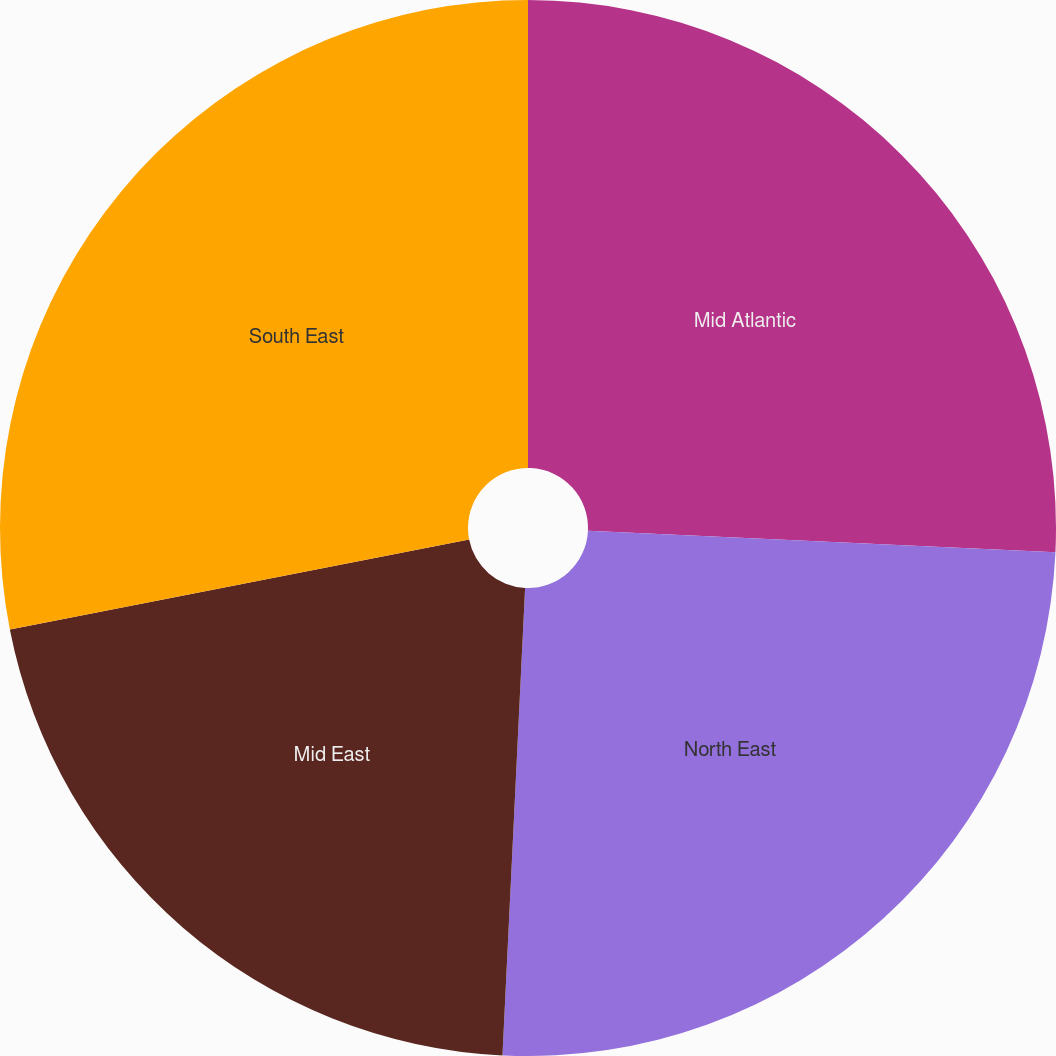Convert chart to OTSL. <chart><loc_0><loc_0><loc_500><loc_500><pie_chart><fcel>Mid Atlantic<fcel>North East<fcel>Mid East<fcel>South East<nl><fcel>25.73%<fcel>25.04%<fcel>21.15%<fcel>28.08%<nl></chart> 